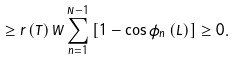<formula> <loc_0><loc_0><loc_500><loc_500>\geq r \left ( T \right ) W \sum _ { n = 1 } ^ { N - 1 } \left [ 1 - \cos \bar { \phi } _ { n } \left ( L \right ) \right ] \geq 0 .</formula> 